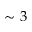<formula> <loc_0><loc_0><loc_500><loc_500>\sim 3</formula> 